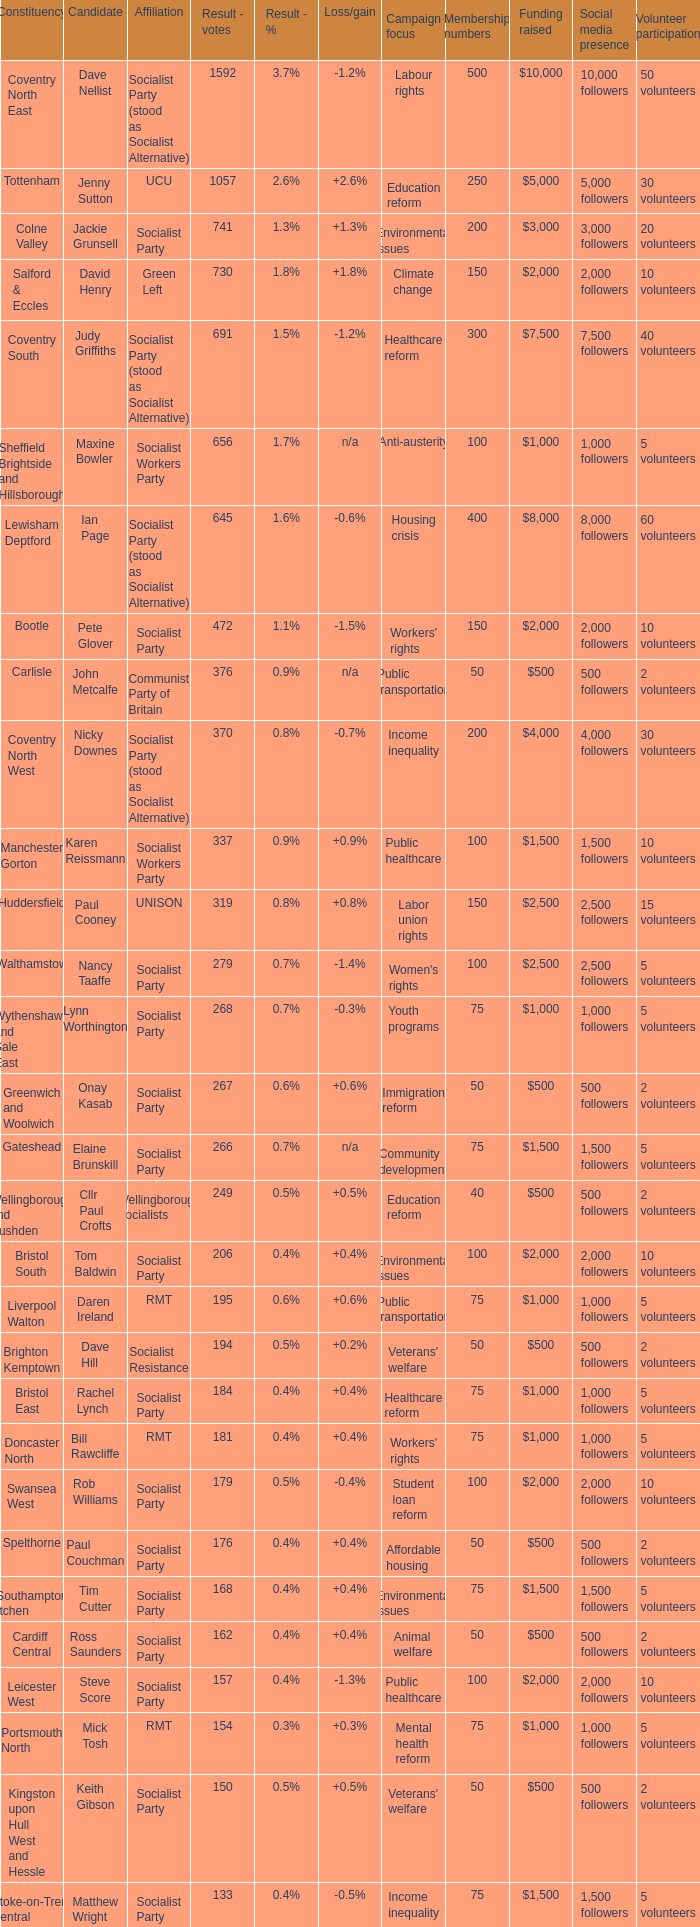What is the largest vote result for the Huddersfield constituency? 319.0. 